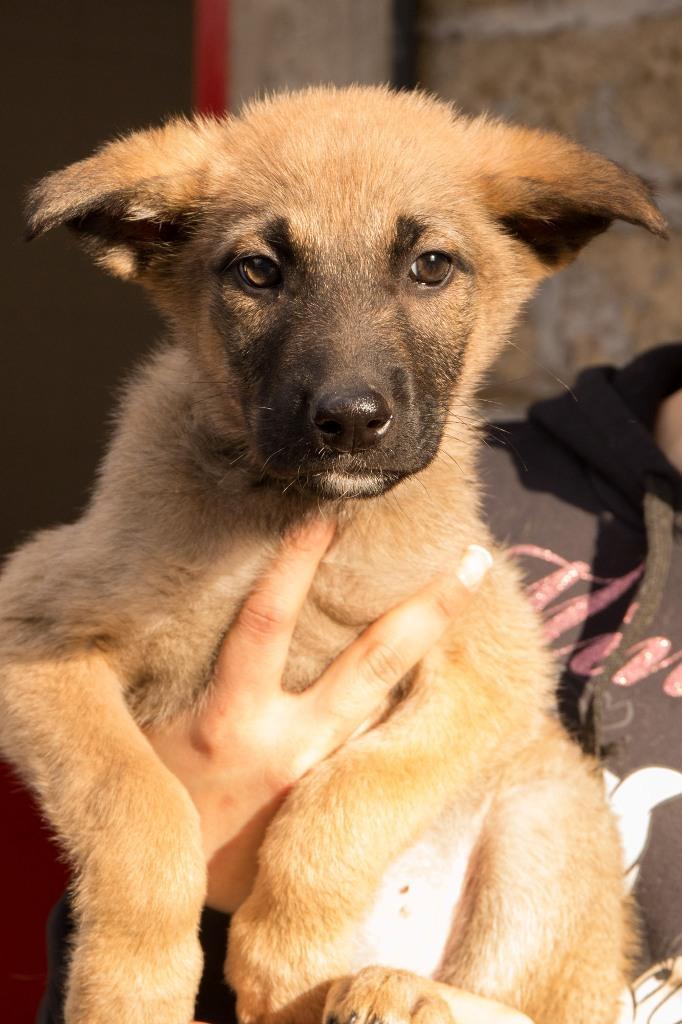Please provide a concise description of this image. In this image we can see a person holding a dog. In the background of the image there is wall. 